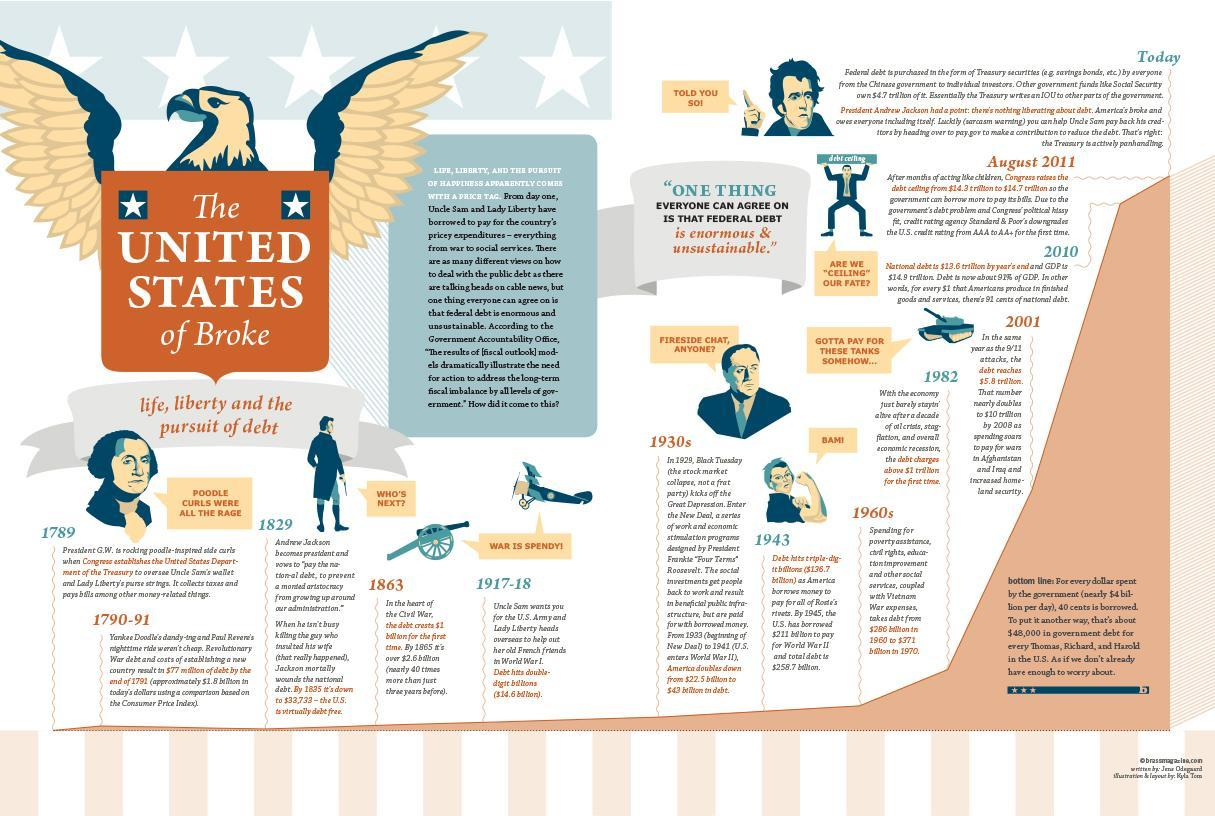In which year did the debts cross $1 billion?
Answer the question with a short phrase. 1863 When did the debts of the US cross triple digit numbers ? 1943 When did the debts of the US hit double digit numbers ? 1917-1918 